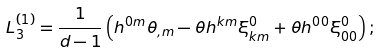<formula> <loc_0><loc_0><loc_500><loc_500>L _ { 3 } ^ { \left ( 1 \right ) } = \frac { 1 } { d - 1 } \left ( h ^ { 0 m } \theta _ { , m } - \theta h ^ { k m } \xi _ { k m } ^ { 0 } + \theta h ^ { 0 0 } \xi _ { 0 0 } ^ { 0 } \right ) ;</formula> 